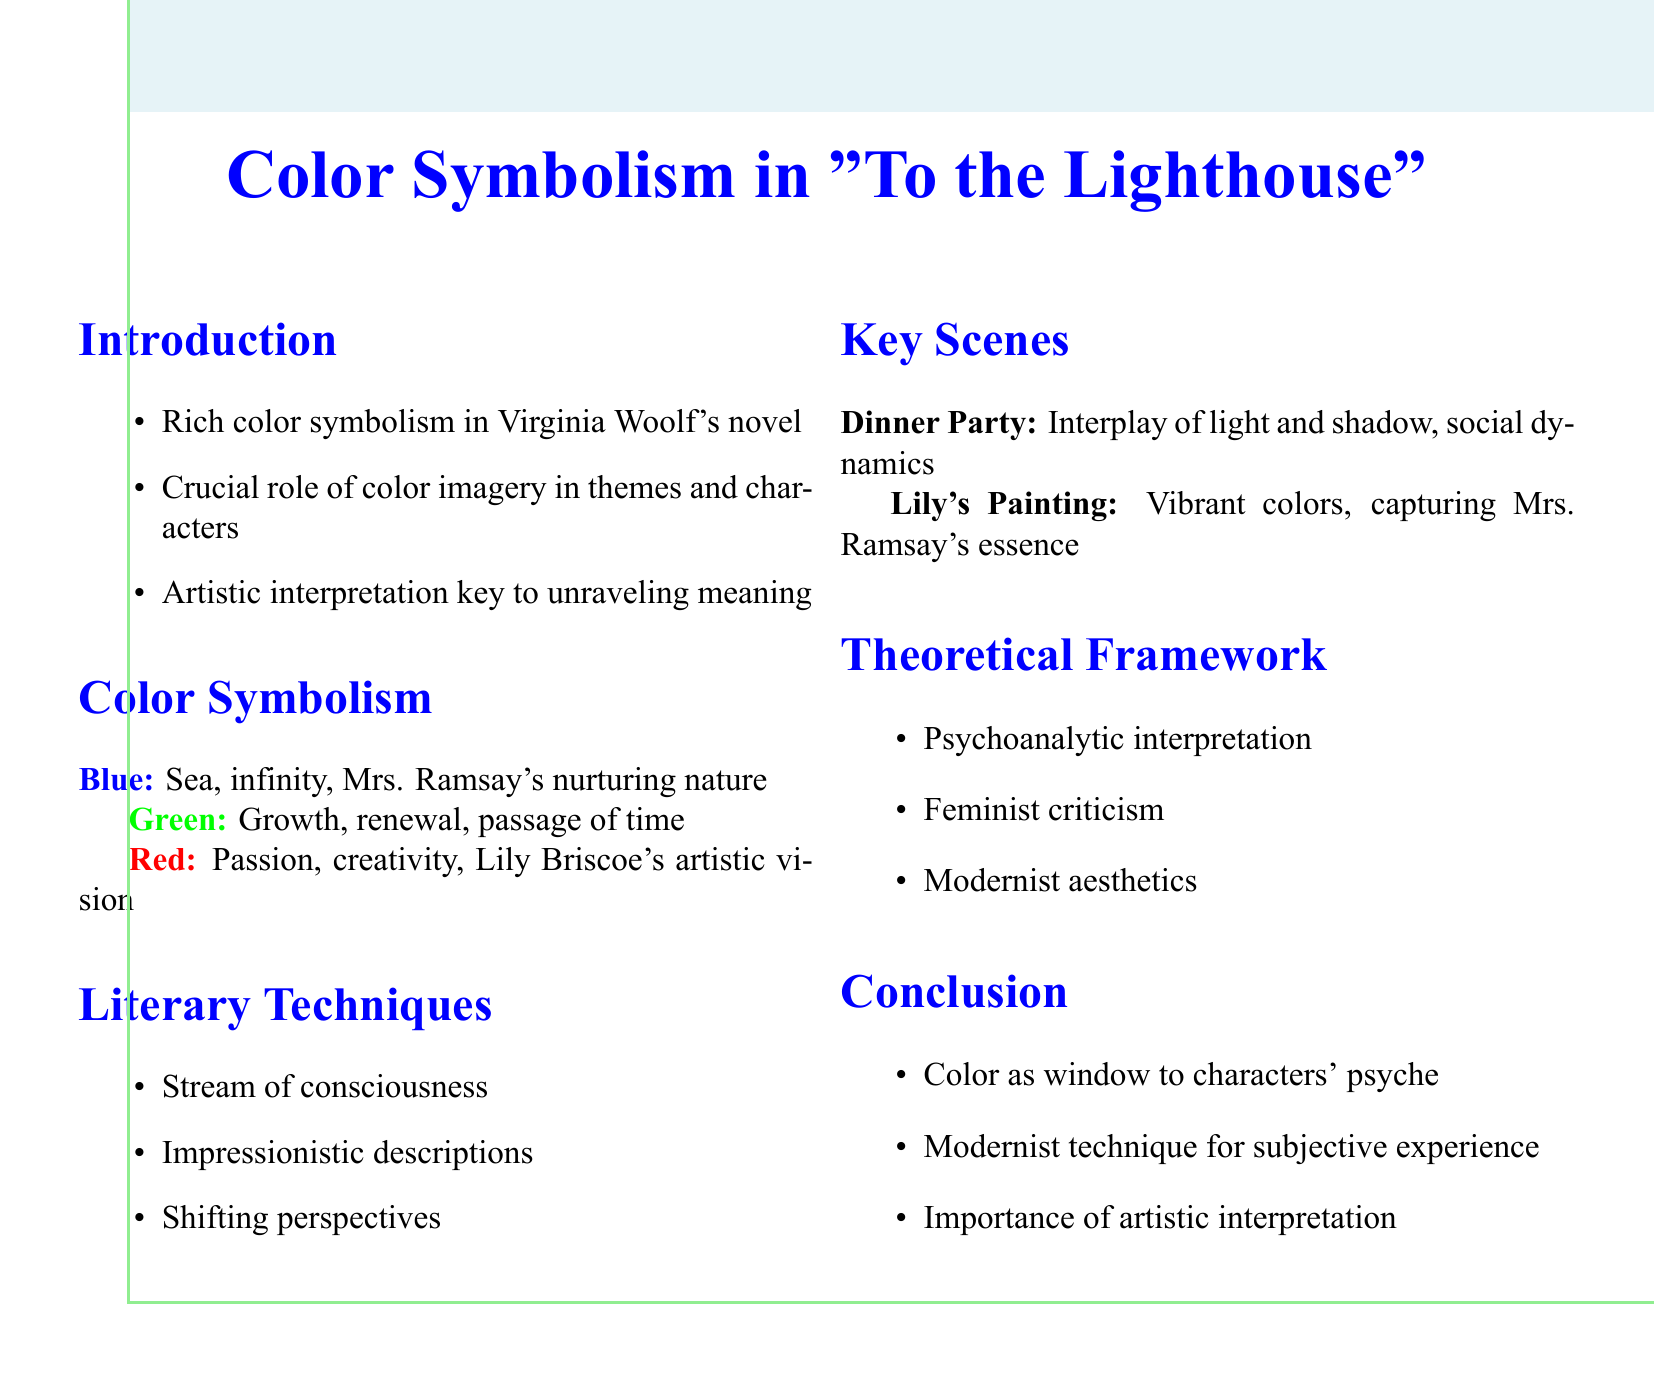What is a primary color that represents the sea? The primary color that represents the sea is blue, as described in the symbolism section of the document.
Answer: Blue What does the color green symbolize in the novel? The color green symbolizes growth, renewal, and the passage of time in the document.
Answer: Growth, renewal, passage of time Which literary technique is mentioned in the document? The document lists "stream of consciousness" as one of the literary techniques used in the novel.
Answer: Stream of consciousness In which scene does the interplay of light and shadow take place? The scene involving the interplay of light and shadow occurs during the dinner party, as indicated in the key scenes section.
Answer: The dinner party Name one approach of the theoretical framework discussed. The theoretical framework mentions several approaches, including psychoanalytic interpretation, as one of them.
Answer: Psychoanalytic interpretation What does Woolf's use of color serve as according to the conclusion? According to the conclusion, Woolf's use of color serves as a window into characters' psyche.
Answer: A window to characters' psyche Which character is associated with the color red? The document associates the color red with Lily Briscoe, highlighting her artistic vision.
Answer: Lily Briscoe How is color imagery described in relation to the novel’s themes? Color imagery is described as playing a crucial role in conveying themes and inner worlds of characters in the introduction.
Answer: Crucial role in conveying themes and characters' inner worlds 